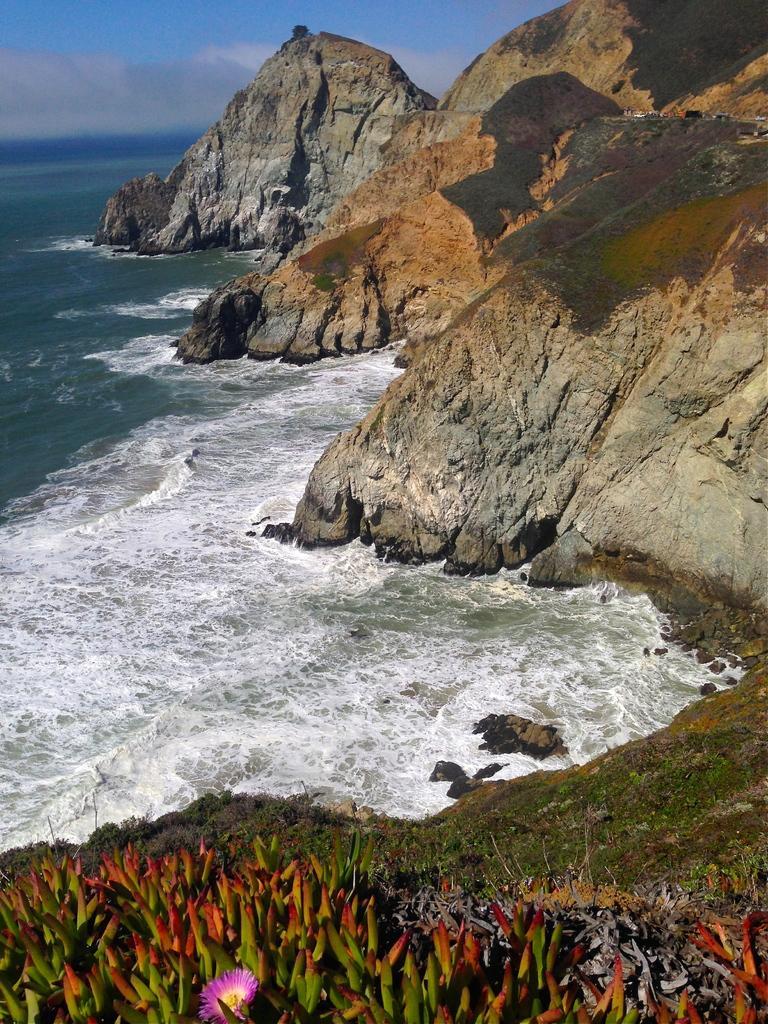Could you give a brief overview of what you see in this image? In this picture there are rock hills towards the right. Beside it there is water. At the bottom there are plants with flowers. 